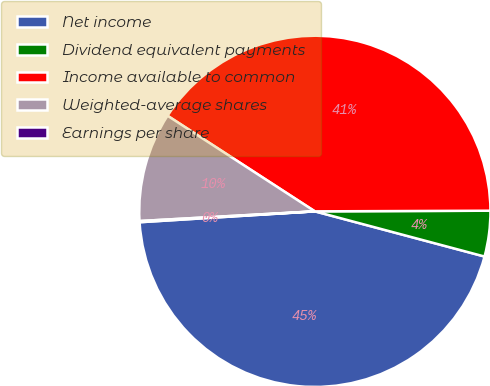Convert chart to OTSL. <chart><loc_0><loc_0><loc_500><loc_500><pie_chart><fcel>Net income<fcel>Dividend equivalent payments<fcel>Income available to common<fcel>Weighted-average shares<fcel>Earnings per share<nl><fcel>44.87%<fcel>4.2%<fcel>40.78%<fcel>10.04%<fcel>0.11%<nl></chart> 